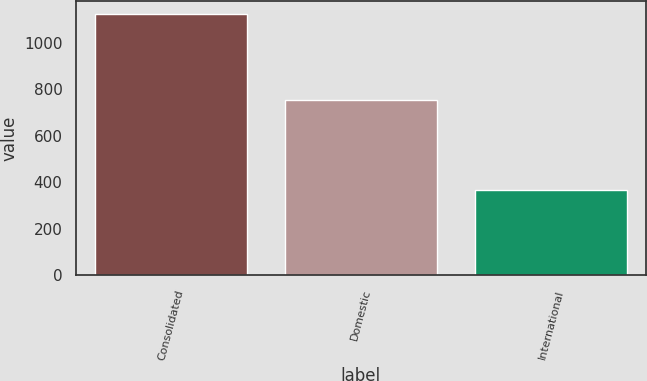Convert chart. <chart><loc_0><loc_0><loc_500><loc_500><bar_chart><fcel>Consolidated<fcel>Domestic<fcel>International<nl><fcel>1122.8<fcel>756.7<fcel>366.1<nl></chart> 